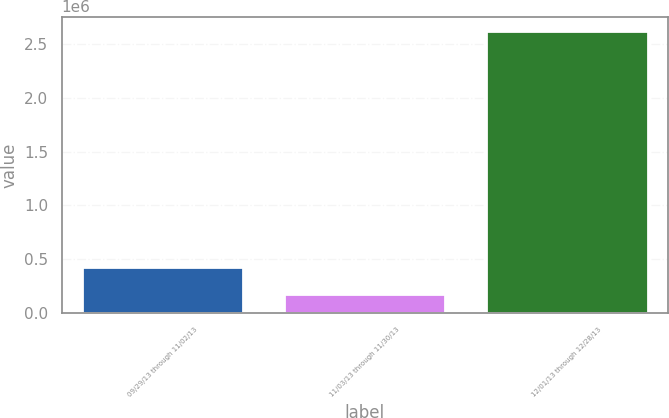<chart> <loc_0><loc_0><loc_500><loc_500><bar_chart><fcel>09/29/13 through 11/02/13<fcel>11/03/13 through 11/30/13<fcel>12/01/13 through 12/28/13<nl><fcel>433702<fcel>182662<fcel>2.6205e+06<nl></chart> 